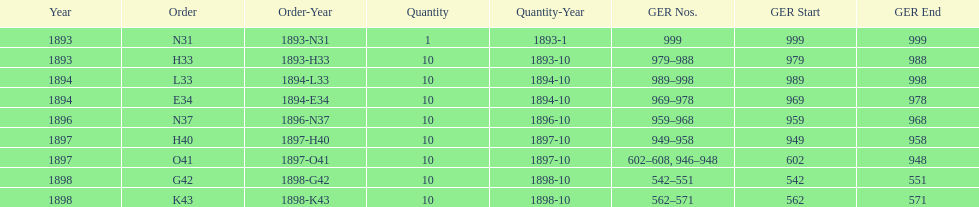Which had more ger numbers, 1898 or 1893? 1898. 